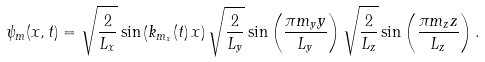Convert formula to latex. <formula><loc_0><loc_0><loc_500><loc_500>\psi _ { m } ( { x } , t ) = \sqrt { \frac { 2 } { L _ { x } } } \sin \left ( k _ { m _ { x } } ( t ) \, x \right ) \sqrt { \frac { 2 } { L _ { y } } } \sin \left ( \frac { \pi m _ { y } y } { L _ { y } } \right ) \sqrt { \frac { 2 } { L _ { z } } } \sin \left ( \frac { \pi m _ { z } z } { L _ { z } } \right ) .</formula> 